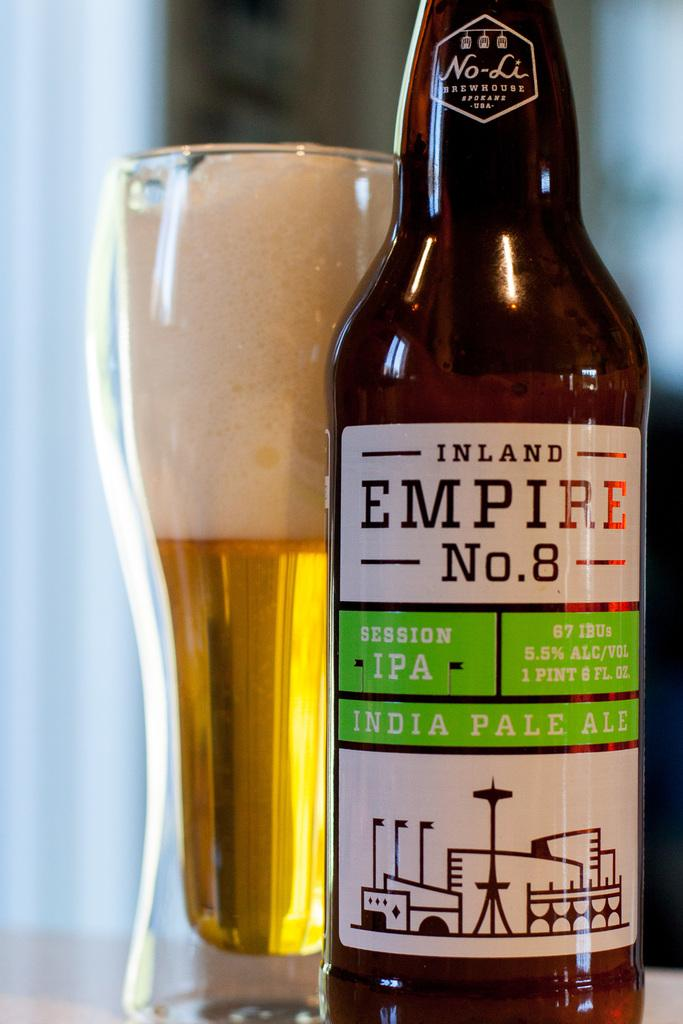<image>
Provide a brief description of the given image. A bottle of Inland Empire No. 8 India Pale Ale beer is poured in a glass. 